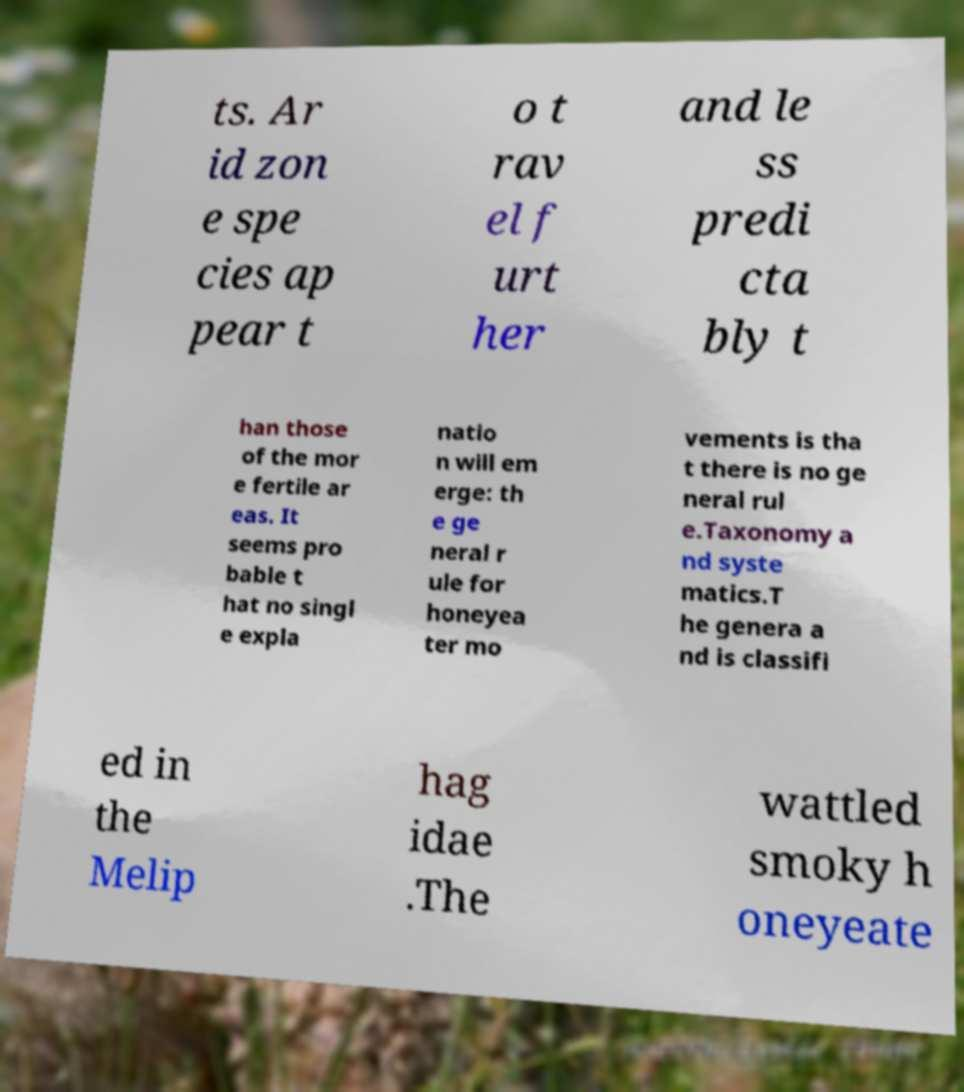For documentation purposes, I need the text within this image transcribed. Could you provide that? ts. Ar id zon e spe cies ap pear t o t rav el f urt her and le ss predi cta bly t han those of the mor e fertile ar eas. It seems pro bable t hat no singl e expla natio n will em erge: th e ge neral r ule for honeyea ter mo vements is tha t there is no ge neral rul e.Taxonomy a nd syste matics.T he genera a nd is classifi ed in the Melip hag idae .The wattled smoky h oneyeate 